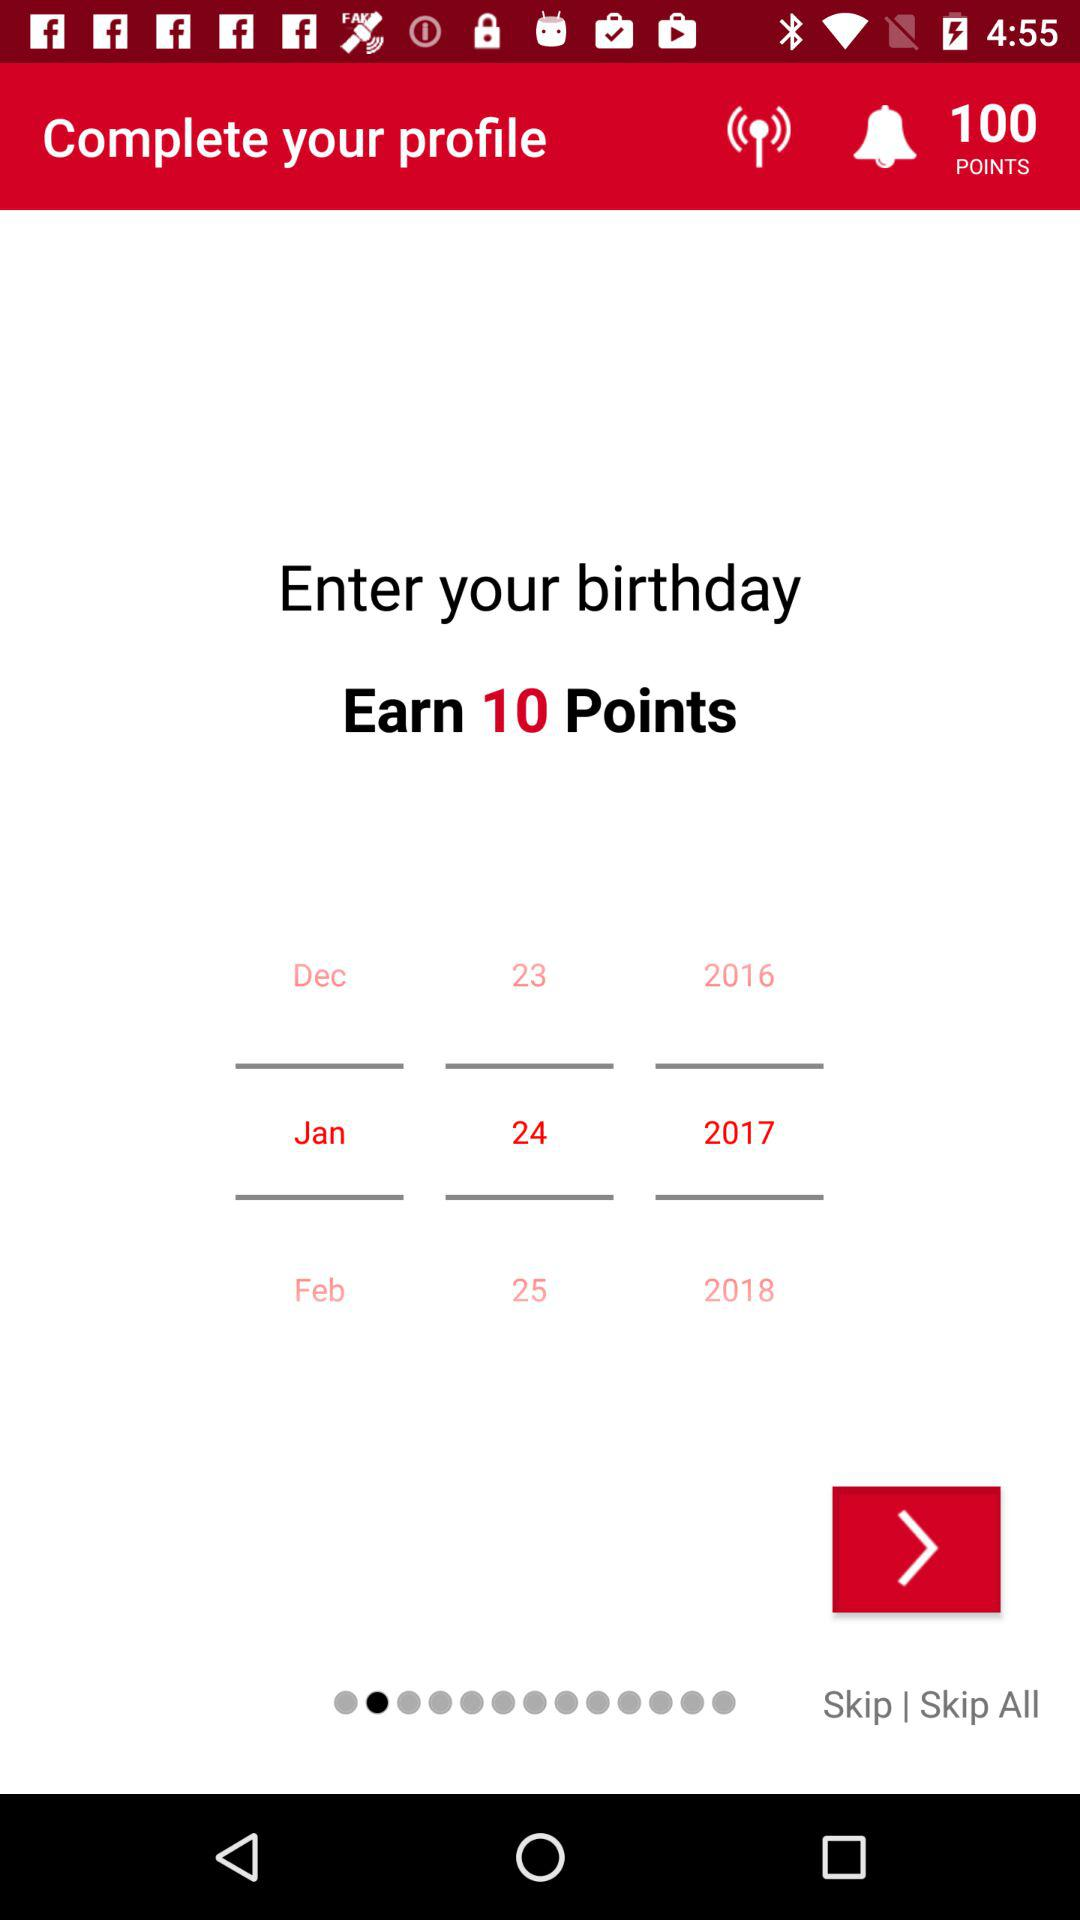What are the total points? The total points are 100. 